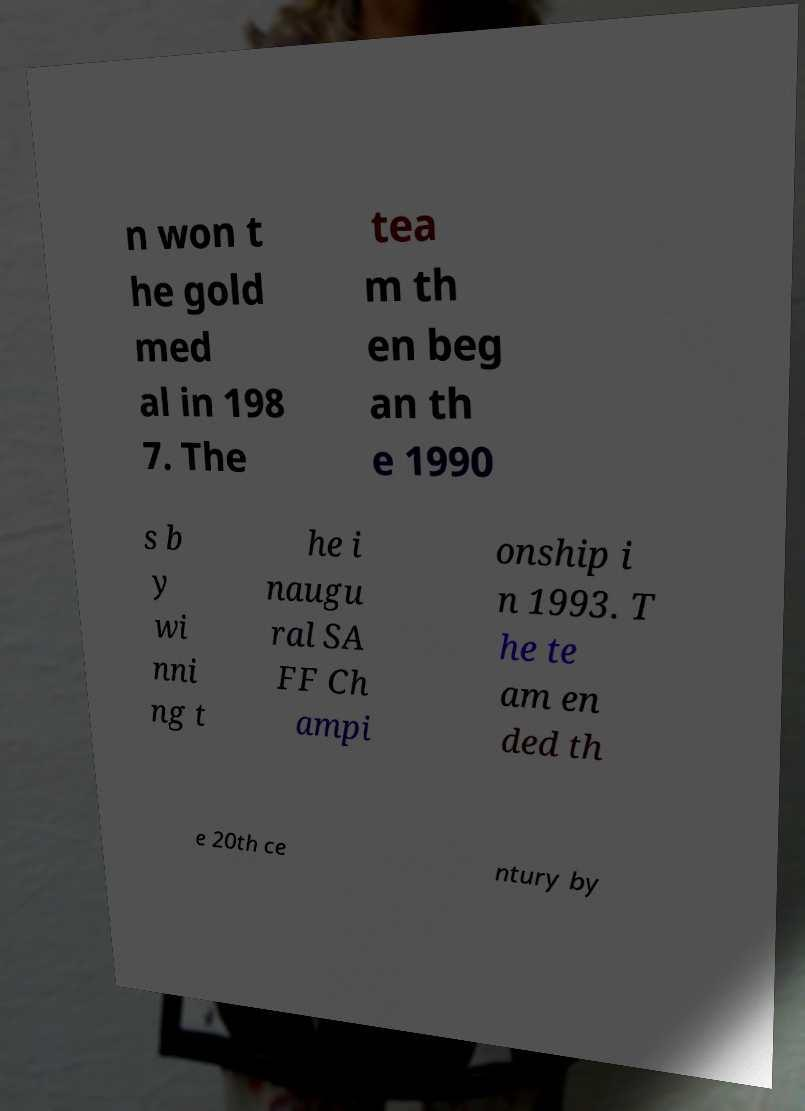Can you read and provide the text displayed in the image?This photo seems to have some interesting text. Can you extract and type it out for me? n won t he gold med al in 198 7. The tea m th en beg an th e 1990 s b y wi nni ng t he i naugu ral SA FF Ch ampi onship i n 1993. T he te am en ded th e 20th ce ntury by 